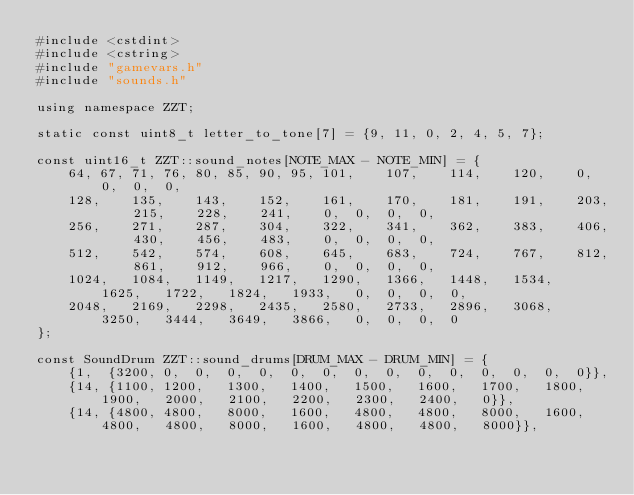Convert code to text. <code><loc_0><loc_0><loc_500><loc_500><_C++_>#include <cstdint>
#include <cstring>
#include "gamevars.h"
#include "sounds.h"

using namespace ZZT;

static const uint8_t letter_to_tone[7] = {9, 11, 0, 2, 4, 5, 7};

const uint16_t ZZT::sound_notes[NOTE_MAX - NOTE_MIN] = {
	64,	67,	71,	76,	80,	85,	90,	95,	101,	107,	114,	120,	0,	0,	0,	0,
	128,	135,	143,	152,	161,	170,	181,	191,	203,	215,	228,	241,	0,	0,	0,	0,
	256,	271,	287,	304,	322,	341,	362,	383,	406,	430,	456,	483,	0,	0,	0,	0,
	512,	542,	574,	608,	645,	683,	724,	767,	812,	861,	912,	966,	0,	0,	0,	0,
	1024,	1084,	1149,	1217,	1290,	1366,	1448,	1534,	1625,	1722,	1824,	1933,	0,	0,	0,	0,
	2048,	2169,	2298,	2435,	2580,	2733,	2896,	3068,	3250,	3444,	3649,	3866,	0,	0,	0,	0
};

const SoundDrum ZZT::sound_drums[DRUM_MAX - DRUM_MIN] = {
	{1,  {3200,	0,	0,	0,	0,	0,	0,	0,	0,	0,	0,	0,	0,	0,	0}},
	{14, {1100,	1200,	1300,	1400,	1500,	1600,	1700,	1800,	1900,	2000,	2100,	2200,	2300,	2400,	0}},
	{14, {4800,	4800,	8000,	1600,	4800,	4800,	8000,	1600,	4800,	4800,	8000,	1600,	4800,	4800,	8000}},</code> 